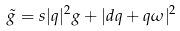<formula> <loc_0><loc_0><loc_500><loc_500>\tilde { g } = s | q | ^ { 2 } g + | d q + q \omega | ^ { 2 }</formula> 